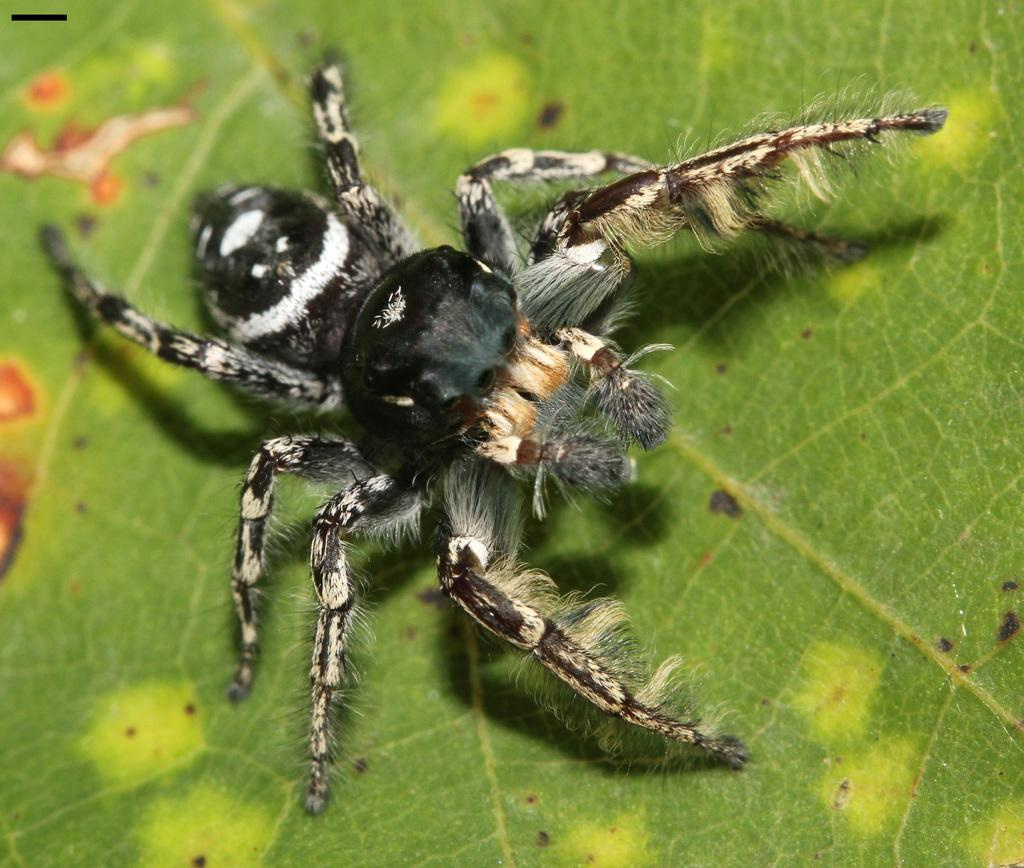What is the main subject of the image? The main subject of the image is a spider. Can you describe the spider's appearance? The spider is black in color. Where is the spider located in the image? The spider is on a leaf. What is the color of the leaf? The leaf is green in color. What type of vegetable is the spider using to burn in the image? There is no vegetable or burning activity present in the image. The spider is simply on a green leaf. 